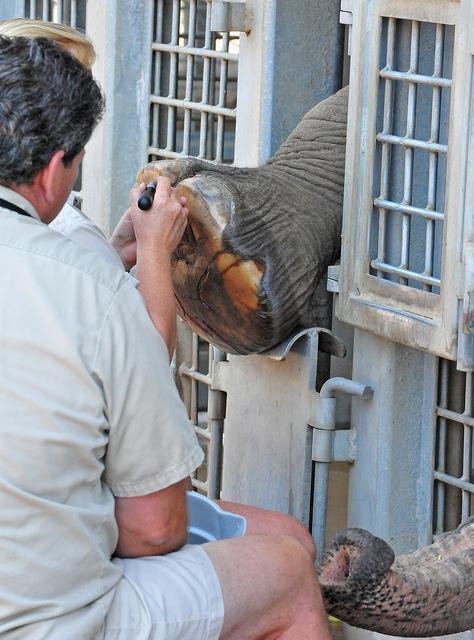How many cats are on the second shelf from the top?
Give a very brief answer. 0. 